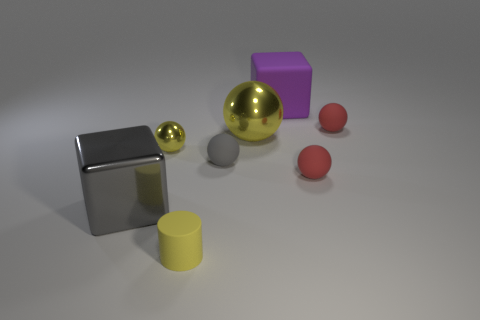Subtract all tiny red rubber balls. How many balls are left? 3 Subtract all yellow cylinders. How many gray spheres are left? 1 Add 2 matte balls. How many objects exist? 10 Subtract all purple blocks. How many blocks are left? 1 Subtract 1 cylinders. How many cylinders are left? 0 Subtract 0 cyan cylinders. How many objects are left? 8 Subtract all cubes. How many objects are left? 6 Subtract all cyan spheres. Subtract all brown blocks. How many spheres are left? 5 Subtract all tiny shiny spheres. Subtract all red balls. How many objects are left? 5 Add 1 tiny gray matte objects. How many tiny gray matte objects are left? 2 